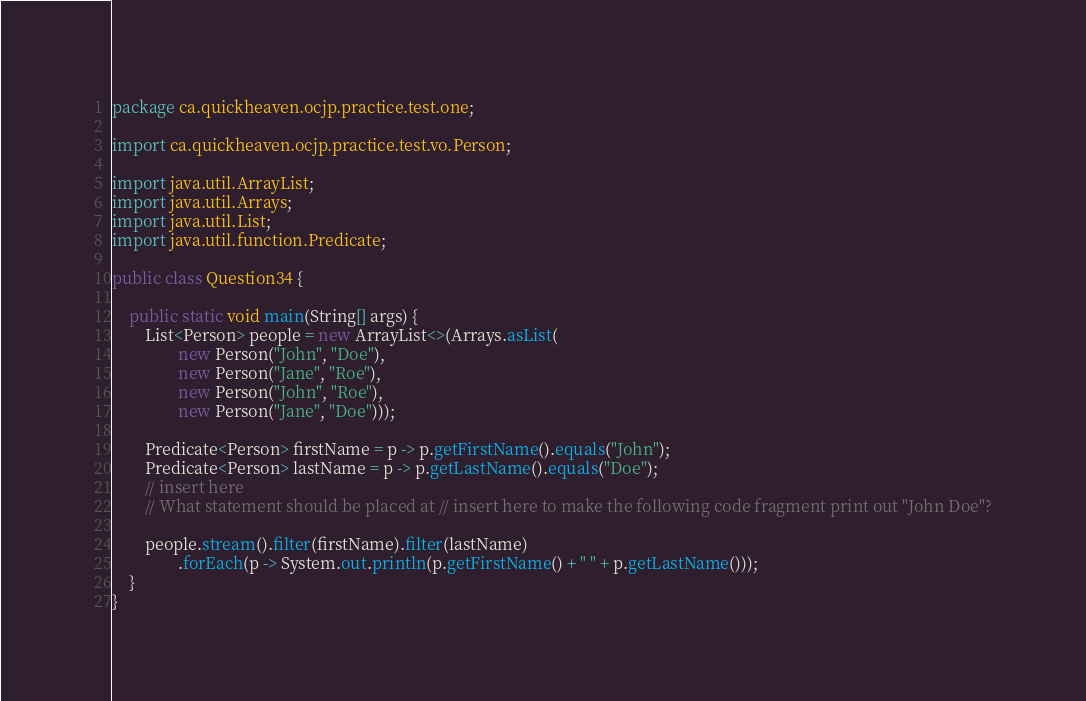<code> <loc_0><loc_0><loc_500><loc_500><_Java_>package ca.quickheaven.ocjp.practice.test.one;

import ca.quickheaven.ocjp.practice.test.vo.Person;

import java.util.ArrayList;
import java.util.Arrays;
import java.util.List;
import java.util.function.Predicate;

public class Question34 {

    public static void main(String[] args) {
        List<Person> people = new ArrayList<>(Arrays.asList(
                new Person("John", "Doe"),
                new Person("Jane", "Roe"),
                new Person("John", "Roe"),
                new Person("Jane", "Doe")));

        Predicate<Person> firstName = p -> p.getFirstName().equals("John");
        Predicate<Person> lastName = p -> p.getLastName().equals("Doe");
        // insert here
        // What statement should be placed at // insert here to make the following code fragment print out "John Doe"?

        people.stream().filter(firstName).filter(lastName)
                .forEach(p -> System.out.println(p.getFirstName() + " " + p.getLastName()));
    }
}
</code> 